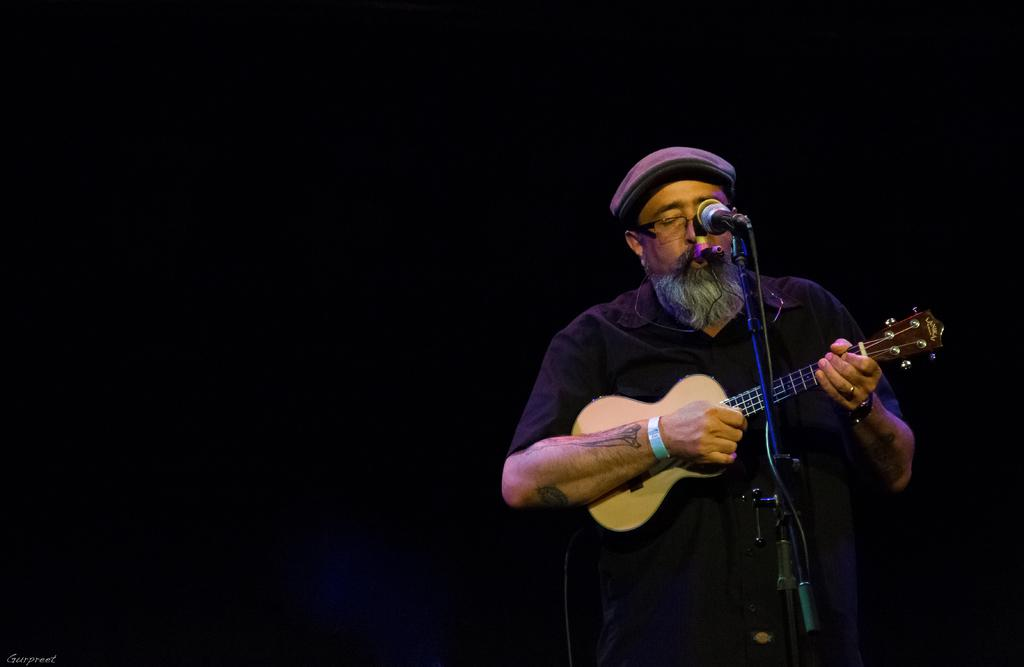What is the man in the image doing? The man is playing the guitar. What object is the man holding while playing the guitar? The man is holding a guitar. What is the man standing in front of? The man is standing in front of a microphone. What is the man wearing on his upper body? The man is wearing a black shirt. What accessories is the man wearing on his head and face? The man is wearing a hat and spectacles. How would you describe the lighting in the image? The background of the image is dark. What type of doctor is standing next to the man in the image? There is no doctor present in the image. How many kittens are sitting on the man's shoulders in the image? There are no kittens present in the image. What time of day is it in the image? The provided facts do not give any information about the time of day, so it cannot be determined from the image. 